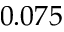Convert formula to latex. <formula><loc_0><loc_0><loc_500><loc_500>0 . 0 7 5</formula> 